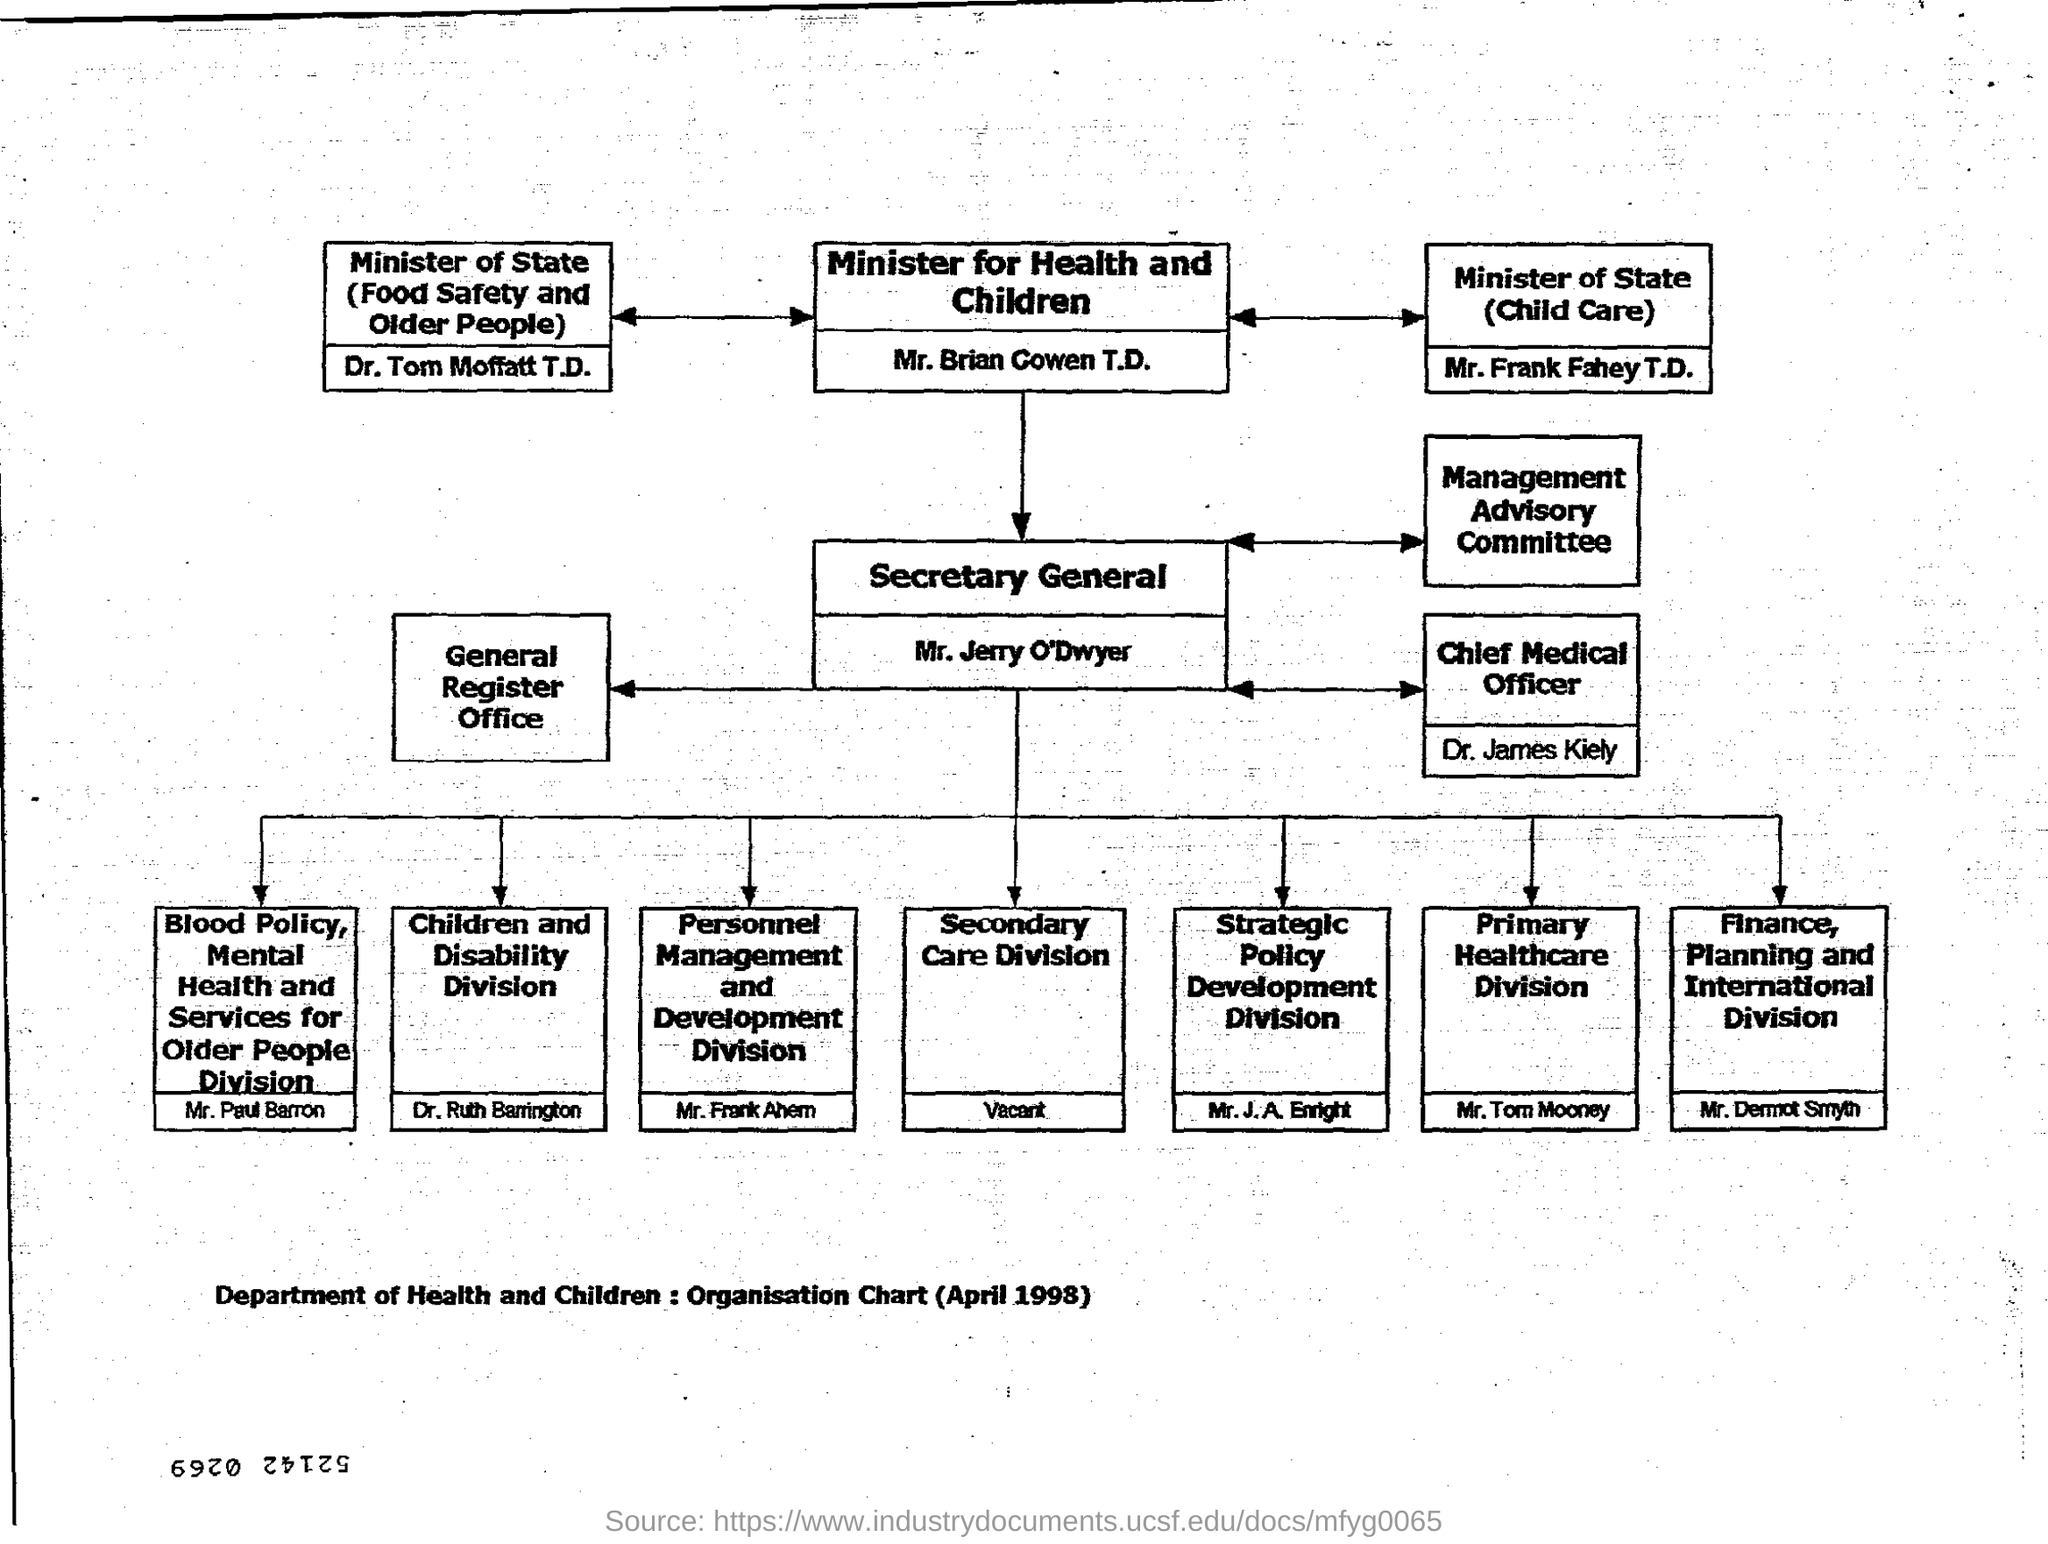Give some essential details in this illustration. Dr. Ruth Barrington is responsible for the Children and Disability Division. The Chief Medical Officer is Dr. James Kiely. The Secondary Care Division is currently vacant. The Organisation Chart (April 1998) belonging to the Department of Health and Children is named "Department of Health and Children : Organisation Chart (April 1998)". The Minister for Health and Children is Mr. Brian Cowen T.D. 